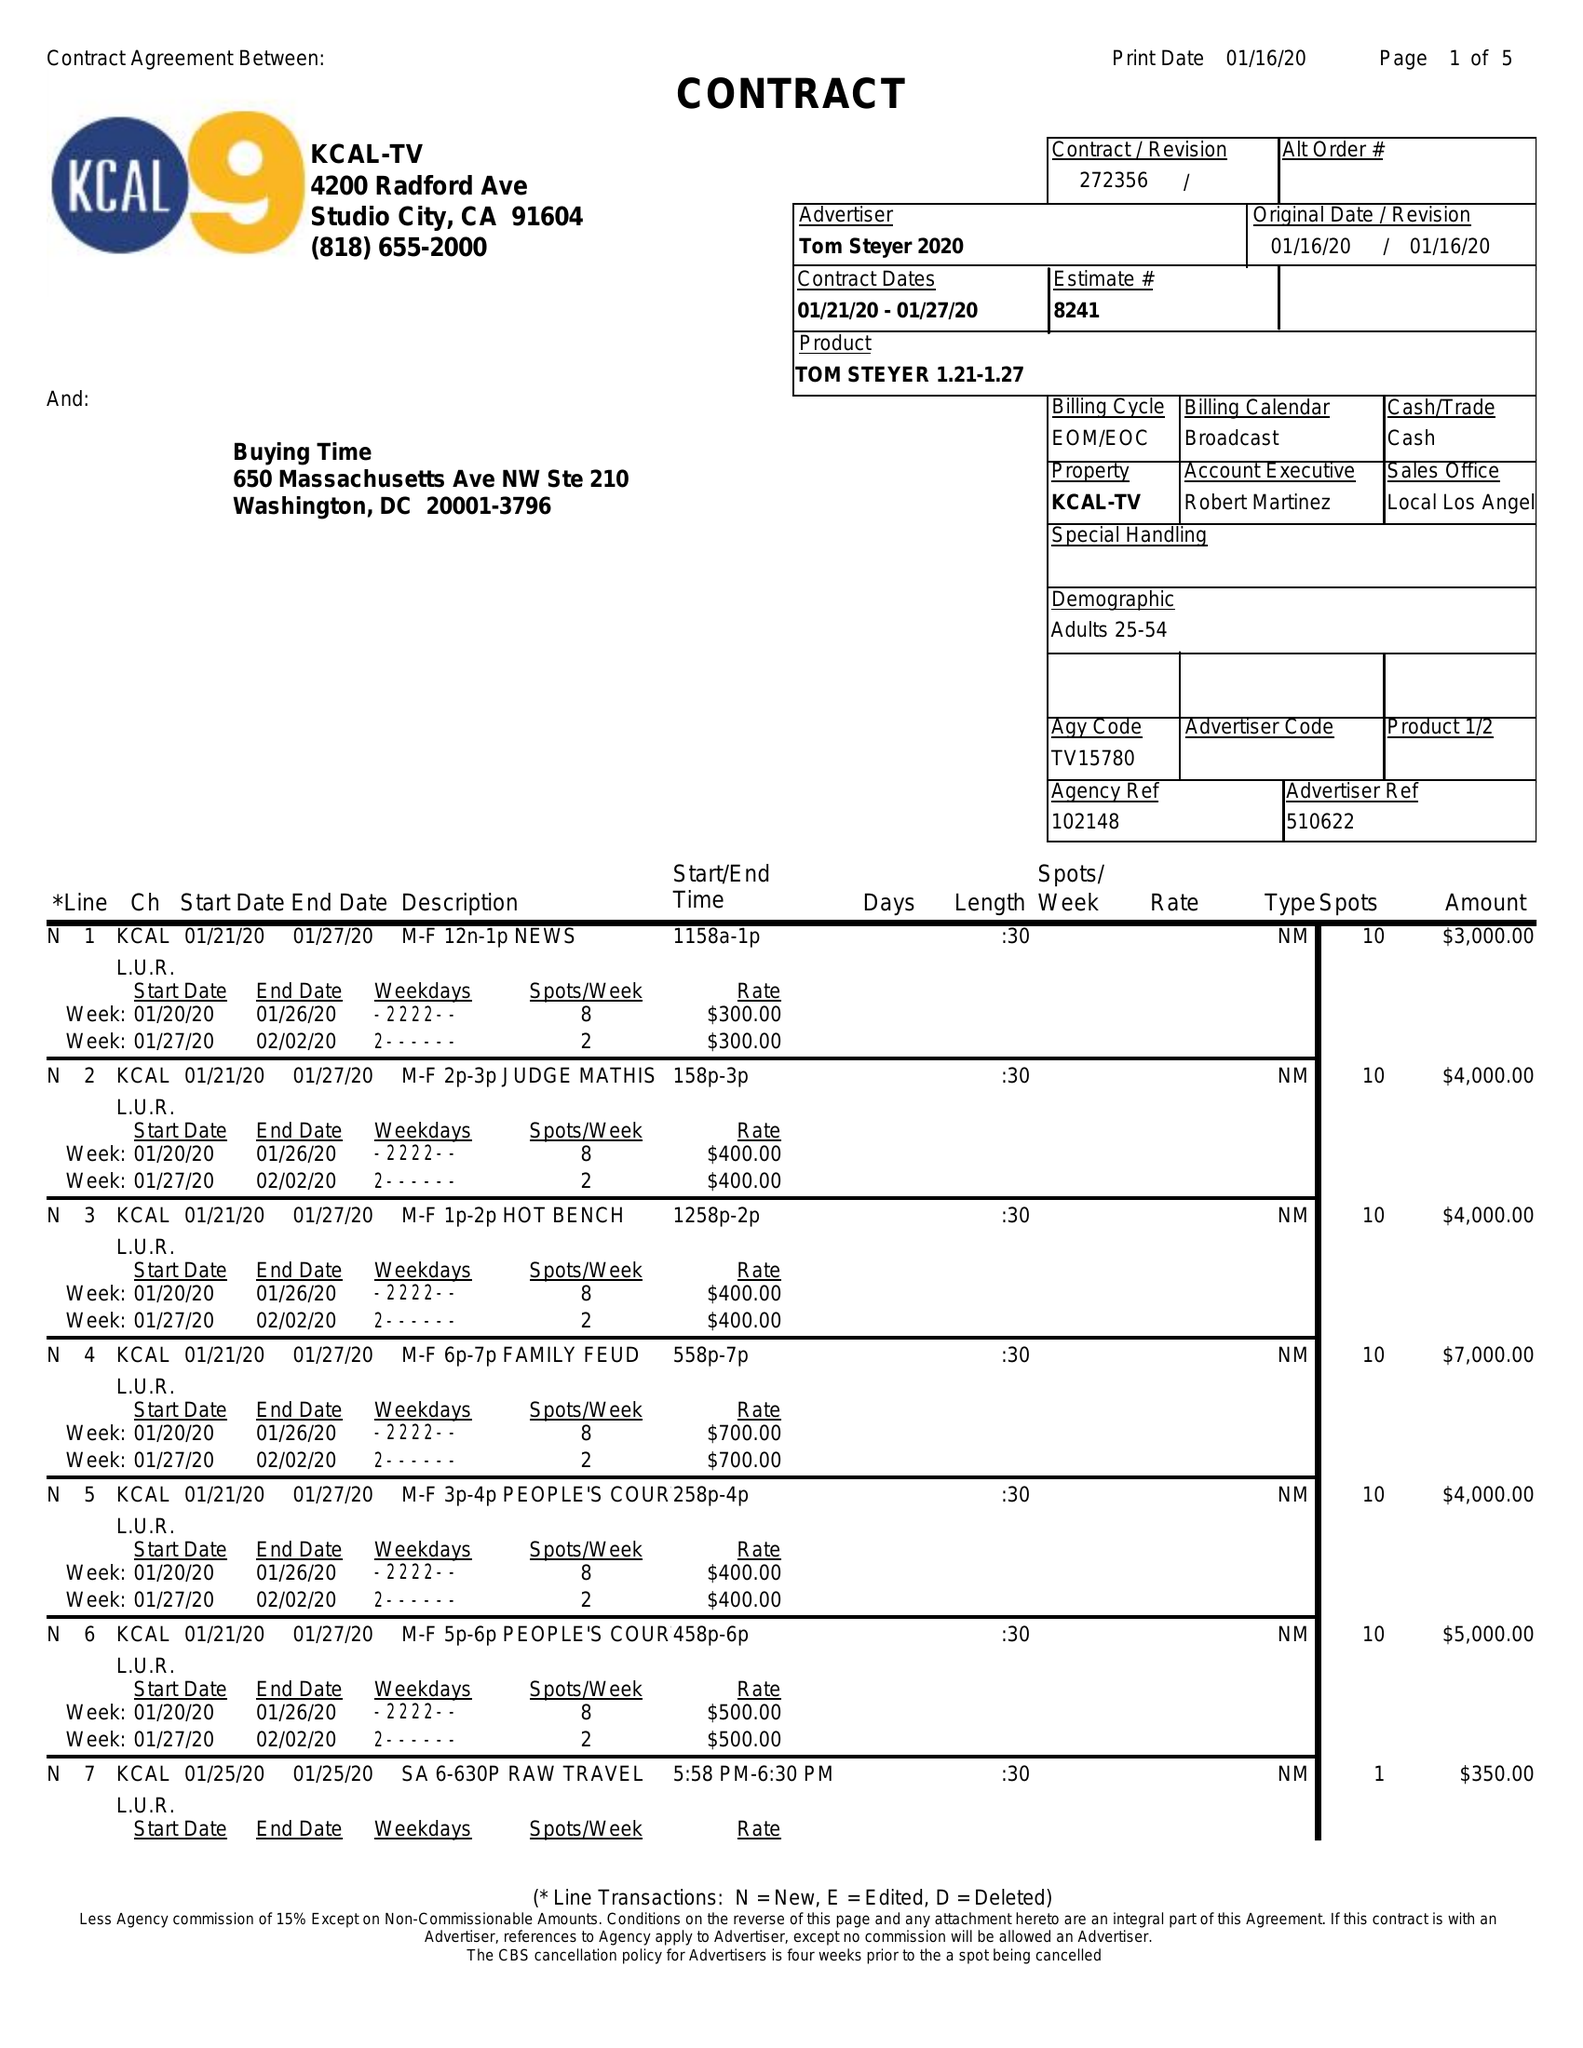What is the value for the flight_to?
Answer the question using a single word or phrase. 01/27/20 